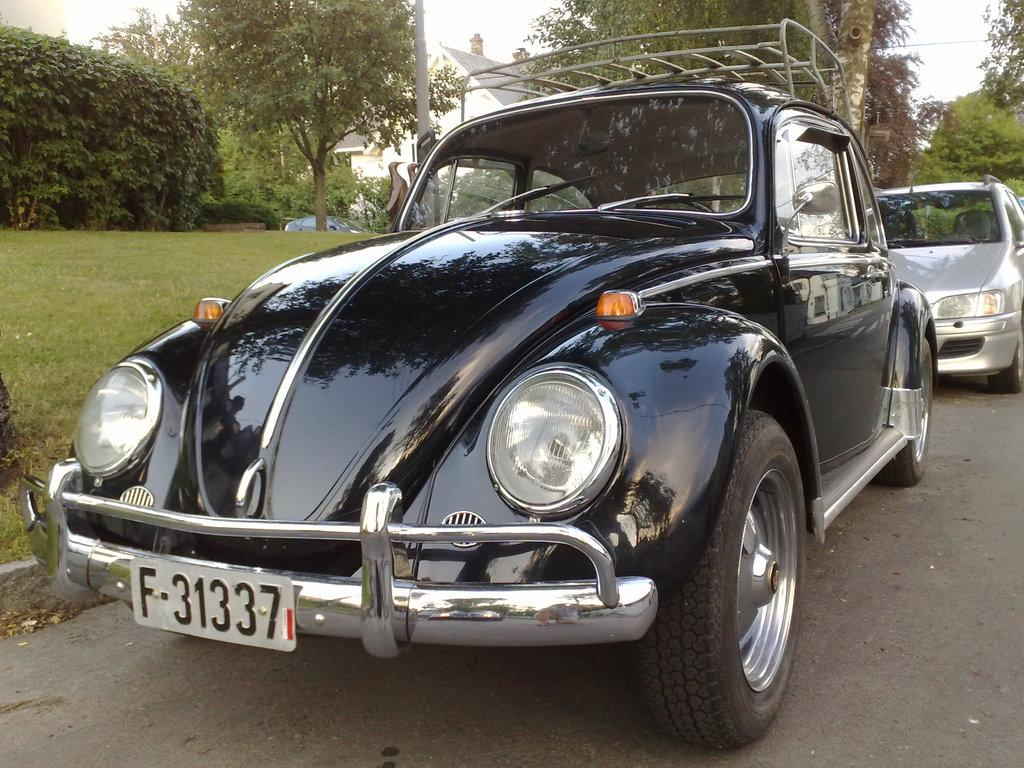What can be seen on the road in the image? There are cars on the road in the image. What type of vegetation is visible in the image? There is grass and trees visible in the image. Can any structures be identified in the image? Yes, there is at least one building present in the image. What else is present in the image besides the cars, grass, trees, and building? There are some unspecified objects in the image. What is visible in the background of the image? The sky is visible in the background of the image. How many knees can be seen in the image? There are no knees visible in the image. What is the weight of the deer in the image? There are no deer present in the image, so their weight cannot be determined. 